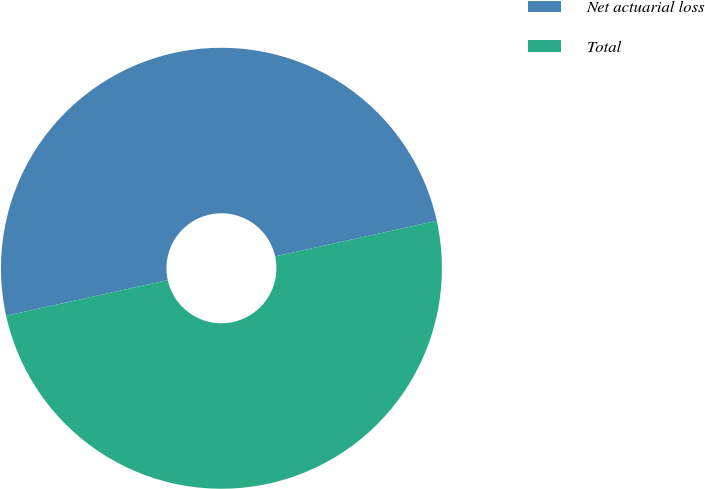Convert chart to OTSL. <chart><loc_0><loc_0><loc_500><loc_500><pie_chart><fcel>Net actuarial loss<fcel>Total<nl><fcel>50.0%<fcel>50.0%<nl></chart> 